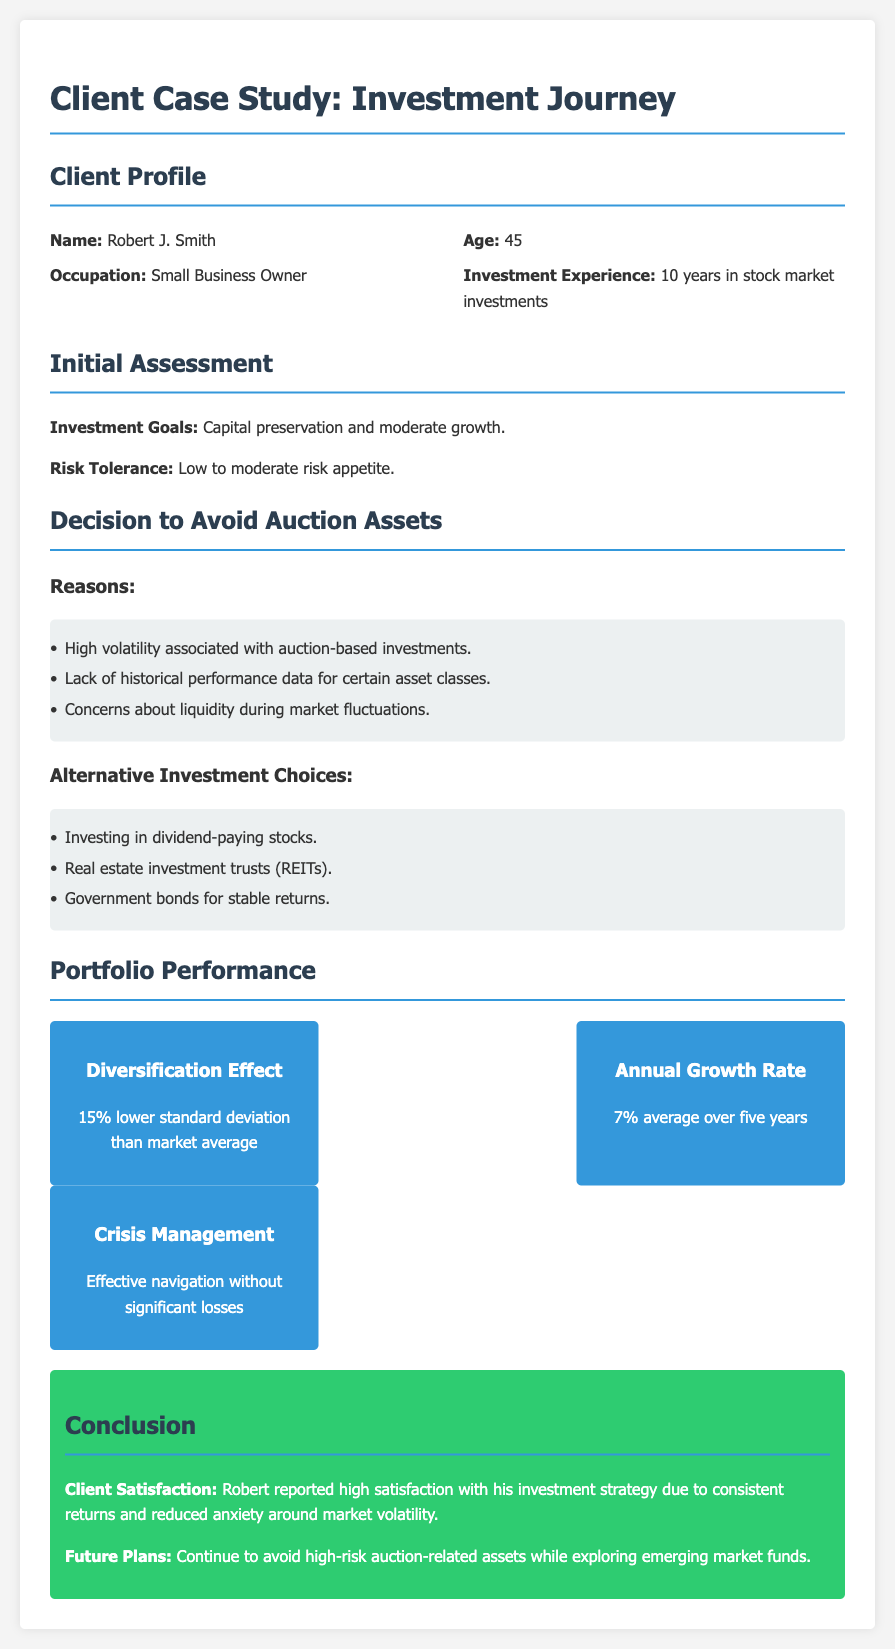What is the name of the client? The name of the client is provided at the beginning of the document under "Client Profile."
Answer: Robert J. Smith What is the client's age? The client's age is listed in the "Client Profile" section of the document.
Answer: 45 What is Robert's risk tolerance? The risk tolerance is mentioned in the "Initial Assessment" section, describing his appetite for risk.
Answer: Low to moderate What are the alternative investment choices listed? The alternative investments are detailed in the "Decision to Avoid Auction Assets" section, where alternatives are presented.
Answer: Dividend-paying stocks, REITs, government bonds What is the average annual growth rate of the portfolio? The average annual growth rate is provided in the "Portfolio Performance" section of the document.
Answer: 7% What is the diversification effect of the portfolio? The diversification effect is outlined in the "Portfolio Performance" section, highlighting its comparison with market averages.
Answer: 15% lower standard deviation than market average Why did Robert avoid auction-related assets? The reasons for avoiding auction-related assets are discussed in the "Decision to Avoid Auction Assets" section.
Answer: High volatility, lack of historical performance data, concerns about liquidity What is the client's satisfaction regarding the investment strategy? Client satisfaction is summarized in the "Conclusion" section, discussing Robert's feelings about his investment strategy.
Answer: High satisfaction 